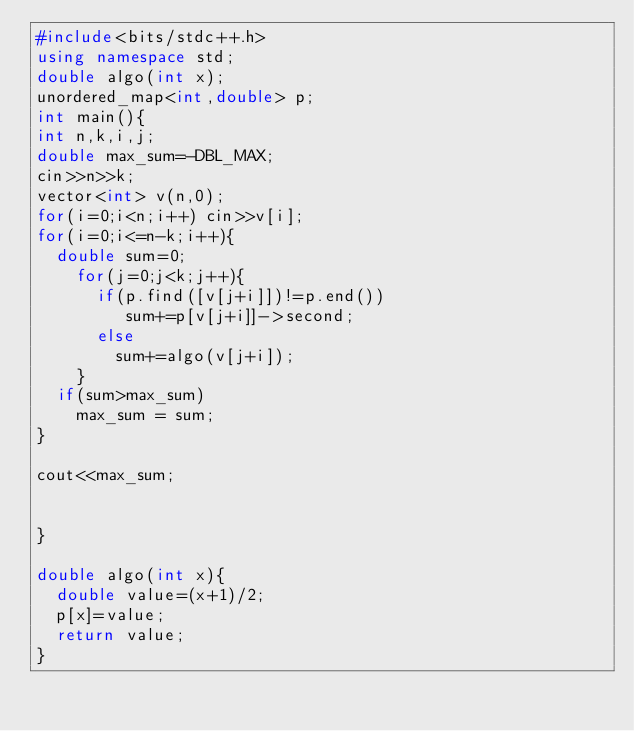<code> <loc_0><loc_0><loc_500><loc_500><_C++_>#include<bits/stdc++.h>
using namespace std;
double algo(int x);
unordered_map<int,double> p;
int main(){
int n,k,i,j;
double max_sum=-DBL_MAX;
cin>>n>>k;
vector<int> v(n,0);
for(i=0;i<n;i++) cin>>v[i]; 
for(i=0;i<=n-k;i++){
  double sum=0;
	for(j=0;j<k;j++){
      if(p.find([v[j+i]])!=p.end())
         sum+=p[v[j+i]]->second;
      else
		sum+=algo(v[j+i]);
	}
  if(sum>max_sum)
    max_sum = sum;
}
  
cout<<max_sum;
  
  
}

double algo(int x){
  double value=(x+1)/2;
  p[x]=value;
  return value;
}  
  
</code> 